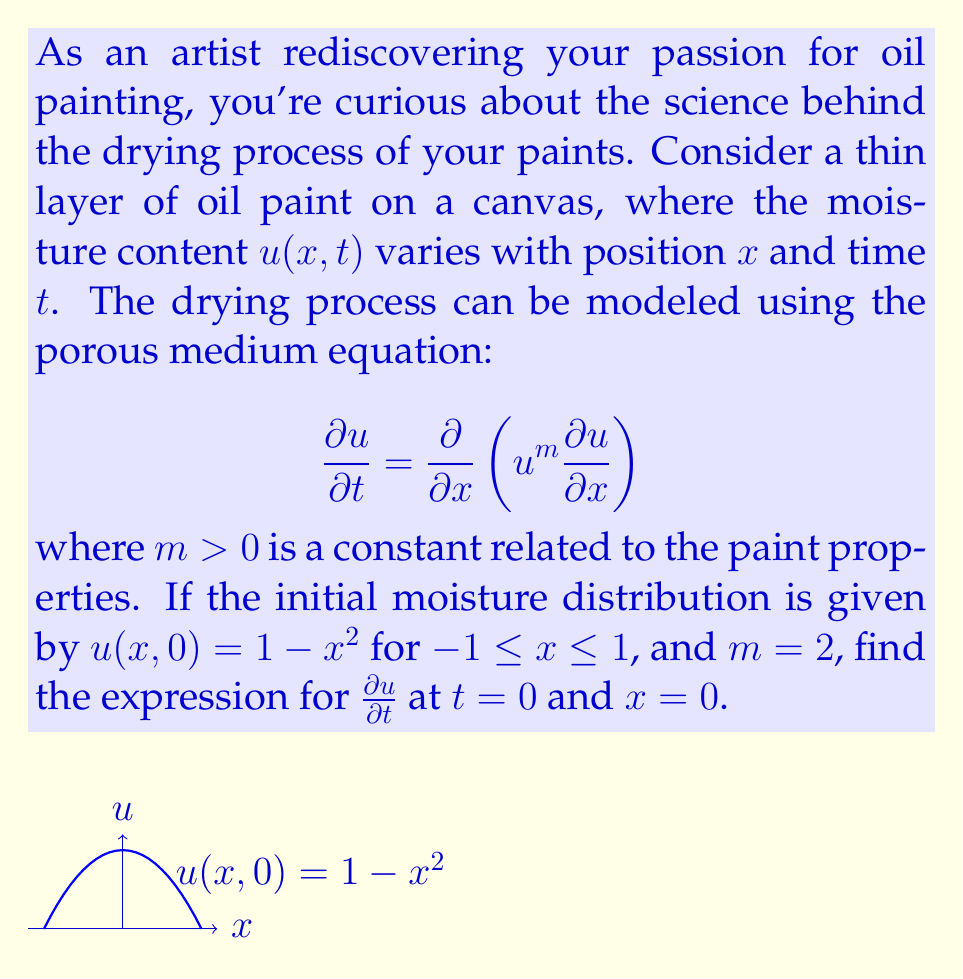Can you solve this math problem? Let's approach this step-by-step:

1) We are given the porous medium equation:
   $$\frac{\partial u}{\partial t} = \frac{\partial}{\partial x}\left(u^m\frac{\partial u}{\partial x}\right)$$

2) We're told that $m = 2$, so our equation becomes:
   $$\frac{\partial u}{\partial t} = \frac{\partial}{\partial x}\left(u^2\frac{\partial u}{\partial x}\right)$$

3) To find $\frac{\partial u}{\partial t}$ at $t = 0$ and $x = 0$, we need to evaluate the right-hand side of this equation at these points.

4) First, let's find $\frac{\partial u}{\partial x}$:
   Given $u(x,0) = 1 - x^2$, we have $\frac{\partial u}{\partial x} = -2x$ at $t = 0$.

5) Now, we need to evaluate $u^2\frac{\partial u}{\partial x}$:
   At $t = 0$, $u^2\frac{\partial u}{\partial x} = (1-x^2)^2(-2x)$

6) Next, we need to find $\frac{\partial}{\partial x}\left(u^2\frac{\partial u}{\partial x}\right)$:
   $$\frac{\partial}{\partial x}\left((1-x^2)^2(-2x)\right) = -2(1-x^2)^2 + 8x^2(1-x^2)$$

7) Finally, we evaluate this at $x = 0$:
   At $x = 0$, $(1-x^2)^2 = 1$ and $8x^2(1-x^2) = 0$

8) Therefore, at $t = 0$ and $x = 0$:
   $$\frac{\partial u}{\partial t} = -2$$
Answer: $-2$ 